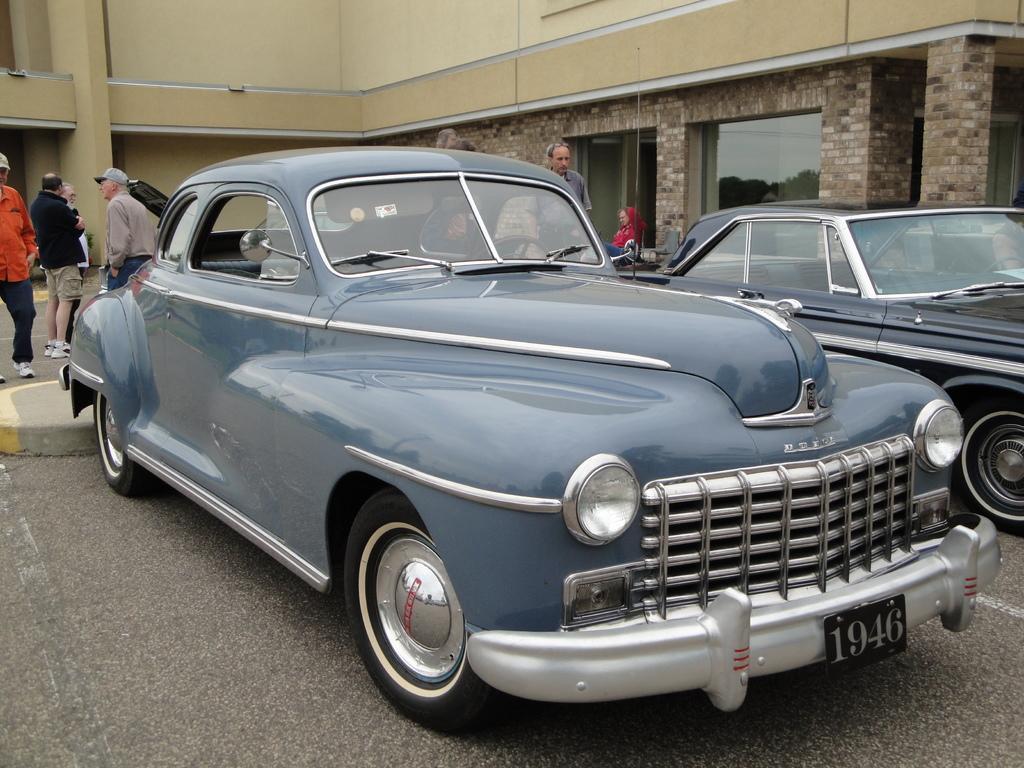Describe this image in one or two sentences. In this image there are two cars parked, behind the cars there are few persons standing and few are walking. In the background there is a building. 